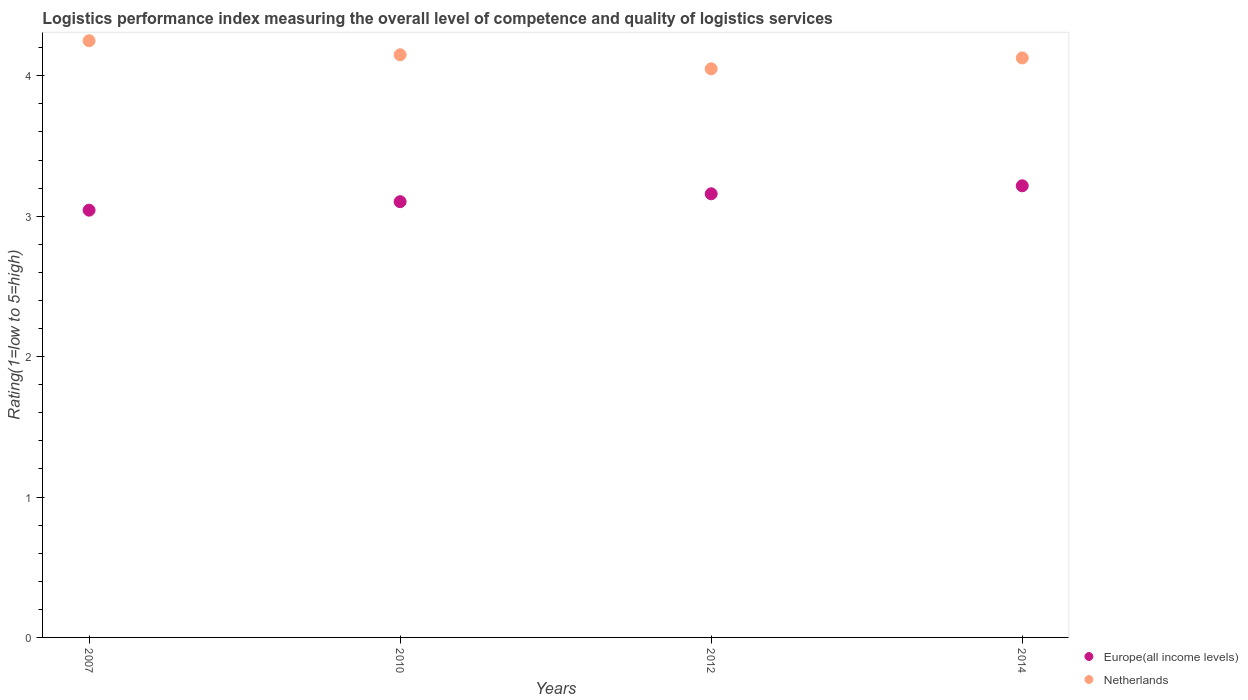Is the number of dotlines equal to the number of legend labels?
Your answer should be compact. Yes. What is the Logistic performance index in Netherlands in 2010?
Ensure brevity in your answer.  4.15. Across all years, what is the maximum Logistic performance index in Europe(all income levels)?
Ensure brevity in your answer.  3.22. Across all years, what is the minimum Logistic performance index in Europe(all income levels)?
Your answer should be compact. 3.04. What is the total Logistic performance index in Netherlands in the graph?
Offer a terse response. 16.58. What is the difference between the Logistic performance index in Europe(all income levels) in 2007 and that in 2012?
Offer a very short reply. -0.12. What is the difference between the Logistic performance index in Netherlands in 2010 and the Logistic performance index in Europe(all income levels) in 2007?
Your answer should be very brief. 1.11. What is the average Logistic performance index in Europe(all income levels) per year?
Provide a short and direct response. 3.13. In the year 2010, what is the difference between the Logistic performance index in Netherlands and Logistic performance index in Europe(all income levels)?
Your response must be concise. 1.05. What is the ratio of the Logistic performance index in Netherlands in 2007 to that in 2012?
Provide a succinct answer. 1.05. Is the Logistic performance index in Europe(all income levels) in 2012 less than that in 2014?
Provide a succinct answer. Yes. Is the difference between the Logistic performance index in Netherlands in 2007 and 2010 greater than the difference between the Logistic performance index in Europe(all income levels) in 2007 and 2010?
Offer a very short reply. Yes. What is the difference between the highest and the second highest Logistic performance index in Europe(all income levels)?
Offer a terse response. 0.06. What is the difference between the highest and the lowest Logistic performance index in Europe(all income levels)?
Give a very brief answer. 0.17. In how many years, is the Logistic performance index in Europe(all income levels) greater than the average Logistic performance index in Europe(all income levels) taken over all years?
Provide a succinct answer. 2. Is the sum of the Logistic performance index in Europe(all income levels) in 2012 and 2014 greater than the maximum Logistic performance index in Netherlands across all years?
Offer a terse response. Yes. How many years are there in the graph?
Make the answer very short. 4. Are the values on the major ticks of Y-axis written in scientific E-notation?
Provide a succinct answer. No. How many legend labels are there?
Give a very brief answer. 2. What is the title of the graph?
Make the answer very short. Logistics performance index measuring the overall level of competence and quality of logistics services. Does "Central Europe" appear as one of the legend labels in the graph?
Keep it short and to the point. No. What is the label or title of the X-axis?
Offer a terse response. Years. What is the label or title of the Y-axis?
Keep it short and to the point. Rating(1=low to 5=high). What is the Rating(1=low to 5=high) of Europe(all income levels) in 2007?
Your response must be concise. 3.04. What is the Rating(1=low to 5=high) in Netherlands in 2007?
Your answer should be very brief. 4.25. What is the Rating(1=low to 5=high) in Europe(all income levels) in 2010?
Keep it short and to the point. 3.1. What is the Rating(1=low to 5=high) in Netherlands in 2010?
Your answer should be compact. 4.15. What is the Rating(1=low to 5=high) in Europe(all income levels) in 2012?
Your answer should be very brief. 3.16. What is the Rating(1=low to 5=high) in Netherlands in 2012?
Offer a very short reply. 4.05. What is the Rating(1=low to 5=high) of Europe(all income levels) in 2014?
Your answer should be very brief. 3.22. What is the Rating(1=low to 5=high) in Netherlands in 2014?
Give a very brief answer. 4.13. Across all years, what is the maximum Rating(1=low to 5=high) of Europe(all income levels)?
Provide a short and direct response. 3.22. Across all years, what is the maximum Rating(1=low to 5=high) of Netherlands?
Offer a terse response. 4.25. Across all years, what is the minimum Rating(1=low to 5=high) of Europe(all income levels)?
Your answer should be very brief. 3.04. Across all years, what is the minimum Rating(1=low to 5=high) of Netherlands?
Your answer should be compact. 4.05. What is the total Rating(1=low to 5=high) of Europe(all income levels) in the graph?
Your response must be concise. 12.52. What is the total Rating(1=low to 5=high) of Netherlands in the graph?
Provide a short and direct response. 16.58. What is the difference between the Rating(1=low to 5=high) of Europe(all income levels) in 2007 and that in 2010?
Provide a short and direct response. -0.06. What is the difference between the Rating(1=low to 5=high) in Europe(all income levels) in 2007 and that in 2012?
Provide a succinct answer. -0.12. What is the difference between the Rating(1=low to 5=high) in Europe(all income levels) in 2007 and that in 2014?
Ensure brevity in your answer.  -0.17. What is the difference between the Rating(1=low to 5=high) in Netherlands in 2007 and that in 2014?
Ensure brevity in your answer.  0.12. What is the difference between the Rating(1=low to 5=high) in Europe(all income levels) in 2010 and that in 2012?
Offer a very short reply. -0.06. What is the difference between the Rating(1=low to 5=high) in Europe(all income levels) in 2010 and that in 2014?
Provide a short and direct response. -0.11. What is the difference between the Rating(1=low to 5=high) of Netherlands in 2010 and that in 2014?
Offer a very short reply. 0.02. What is the difference between the Rating(1=low to 5=high) of Europe(all income levels) in 2012 and that in 2014?
Offer a very short reply. -0.06. What is the difference between the Rating(1=low to 5=high) of Netherlands in 2012 and that in 2014?
Offer a terse response. -0.08. What is the difference between the Rating(1=low to 5=high) in Europe(all income levels) in 2007 and the Rating(1=low to 5=high) in Netherlands in 2010?
Offer a very short reply. -1.11. What is the difference between the Rating(1=low to 5=high) in Europe(all income levels) in 2007 and the Rating(1=low to 5=high) in Netherlands in 2012?
Ensure brevity in your answer.  -1.01. What is the difference between the Rating(1=low to 5=high) in Europe(all income levels) in 2007 and the Rating(1=low to 5=high) in Netherlands in 2014?
Your response must be concise. -1.08. What is the difference between the Rating(1=low to 5=high) in Europe(all income levels) in 2010 and the Rating(1=low to 5=high) in Netherlands in 2012?
Give a very brief answer. -0.95. What is the difference between the Rating(1=low to 5=high) of Europe(all income levels) in 2010 and the Rating(1=low to 5=high) of Netherlands in 2014?
Offer a very short reply. -1.02. What is the difference between the Rating(1=low to 5=high) in Europe(all income levels) in 2012 and the Rating(1=low to 5=high) in Netherlands in 2014?
Offer a terse response. -0.97. What is the average Rating(1=low to 5=high) of Europe(all income levels) per year?
Your answer should be compact. 3.13. What is the average Rating(1=low to 5=high) in Netherlands per year?
Keep it short and to the point. 4.14. In the year 2007, what is the difference between the Rating(1=low to 5=high) in Europe(all income levels) and Rating(1=low to 5=high) in Netherlands?
Provide a succinct answer. -1.21. In the year 2010, what is the difference between the Rating(1=low to 5=high) in Europe(all income levels) and Rating(1=low to 5=high) in Netherlands?
Keep it short and to the point. -1.05. In the year 2012, what is the difference between the Rating(1=low to 5=high) in Europe(all income levels) and Rating(1=low to 5=high) in Netherlands?
Ensure brevity in your answer.  -0.89. In the year 2014, what is the difference between the Rating(1=low to 5=high) of Europe(all income levels) and Rating(1=low to 5=high) of Netherlands?
Offer a very short reply. -0.91. What is the ratio of the Rating(1=low to 5=high) of Europe(all income levels) in 2007 to that in 2010?
Your answer should be compact. 0.98. What is the ratio of the Rating(1=low to 5=high) of Netherlands in 2007 to that in 2010?
Offer a very short reply. 1.02. What is the ratio of the Rating(1=low to 5=high) in Europe(all income levels) in 2007 to that in 2012?
Provide a succinct answer. 0.96. What is the ratio of the Rating(1=low to 5=high) in Netherlands in 2007 to that in 2012?
Keep it short and to the point. 1.05. What is the ratio of the Rating(1=low to 5=high) of Europe(all income levels) in 2007 to that in 2014?
Offer a terse response. 0.95. What is the ratio of the Rating(1=low to 5=high) of Netherlands in 2007 to that in 2014?
Provide a short and direct response. 1.03. What is the ratio of the Rating(1=low to 5=high) of Europe(all income levels) in 2010 to that in 2012?
Your response must be concise. 0.98. What is the ratio of the Rating(1=low to 5=high) in Netherlands in 2010 to that in 2012?
Your answer should be very brief. 1.02. What is the ratio of the Rating(1=low to 5=high) in Europe(all income levels) in 2010 to that in 2014?
Offer a terse response. 0.96. What is the ratio of the Rating(1=low to 5=high) of Netherlands in 2010 to that in 2014?
Make the answer very short. 1.01. What is the ratio of the Rating(1=low to 5=high) in Europe(all income levels) in 2012 to that in 2014?
Offer a very short reply. 0.98. What is the ratio of the Rating(1=low to 5=high) in Netherlands in 2012 to that in 2014?
Offer a very short reply. 0.98. What is the difference between the highest and the second highest Rating(1=low to 5=high) of Europe(all income levels)?
Offer a terse response. 0.06. What is the difference between the highest and the lowest Rating(1=low to 5=high) in Europe(all income levels)?
Your response must be concise. 0.17. 